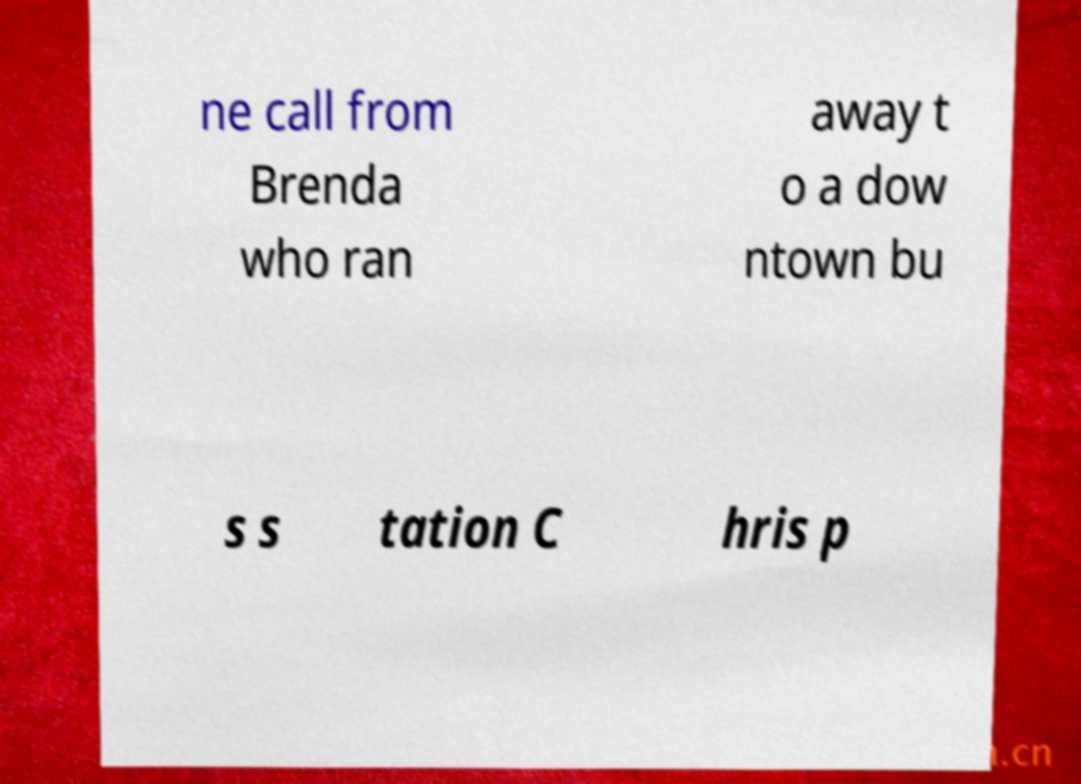Please identify and transcribe the text found in this image. ne call from Brenda who ran away t o a dow ntown bu s s tation C hris p 